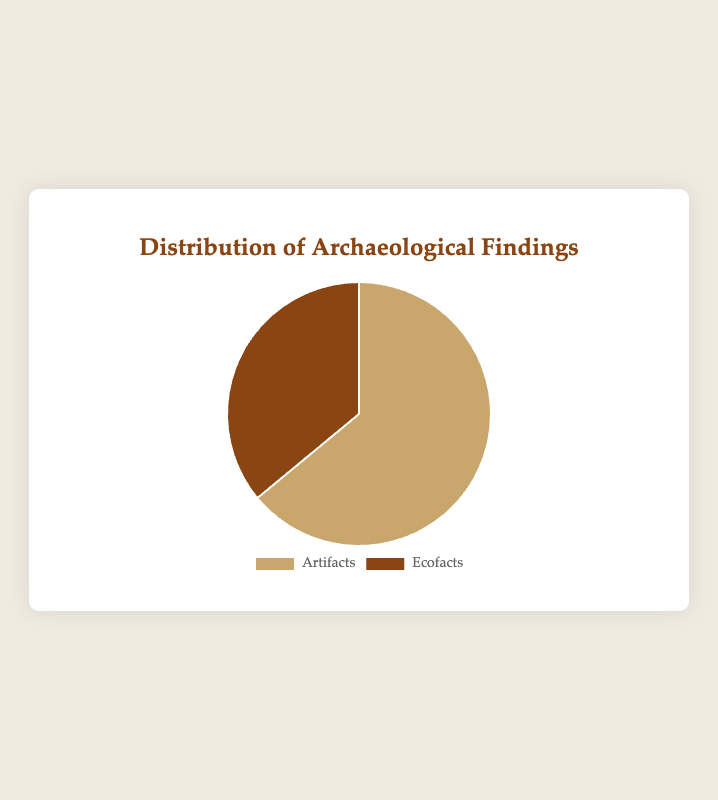What percentage of the findings are artifacts? Artifacts are represented by one of the segments in the pie chart. We can see that artifacts have a count of 3200. To determine the percentage: sum the total findings (3200 artifacts + 1800 ecofacts = 5000). Then, calculate (3200 / 5000) * 100 = 64%.
Answer: 64% What is the difference in counts between artifacts and ecofacts? The counts are directly given in the chart: artifacts (3200) and ecofacts (1800). The difference is found by subtracting the ecofacts from the artifacts: 3200 - 1800 = 1400.
Answer: 1400 Which type of finding is more common? By comparing the two segments of the pie chart, we see that artifacts have a greater count (3200) than ecofacts (1800).
Answer: Artifacts What is the total number of findings represented in the chart? The total number of findings is the sum of artifacts and ecofacts: 3200 artifacts + 1800 ecofacts = 5000.
Answer: 5000 What color represents ecofacts in the chart? In the chart, ecofacts are represented by the segment with the darker brown color.
Answer: Dark brown How many more artifacts are there compared to ecofacts? The counts are given as 3200 for artifacts and 1800 for ecofacts. To find how many more artifacts there are, calculate the difference: 3200 - 1800 = 1400.
Answer: 1400 If the count of artifacts doubles, what would be the new percentage of artifacts? If the count of artifacts doubles, it would be 3200 * 2 = 6400. The new total count would be 6400 (artifacts) + 1800 (ecofacts) = 8200. The new percentage of artifacts would be (6400 / 8200) * 100 ≈ 78%.
Answer: 78% What is the ratio of artifacts to the total findings? The ratio is determined by dividing the number of artifacts (3200) by the total number of findings (5000): 3200 / 5000 = 0.64 or 64%.
Answer: 0.64 or 64% 